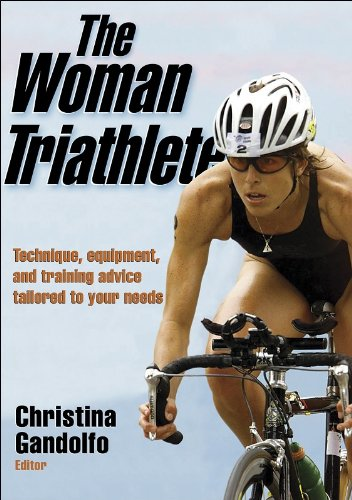What kind of training advice might one expect from this book? Readers can expect comprehensive advice encompassing all three components of a triathlon: swimming, cycling, and running. The book likely covers training schedules, nutrition tips, and techniques to improve endurance and performance specifically geared towards women triathletes. 